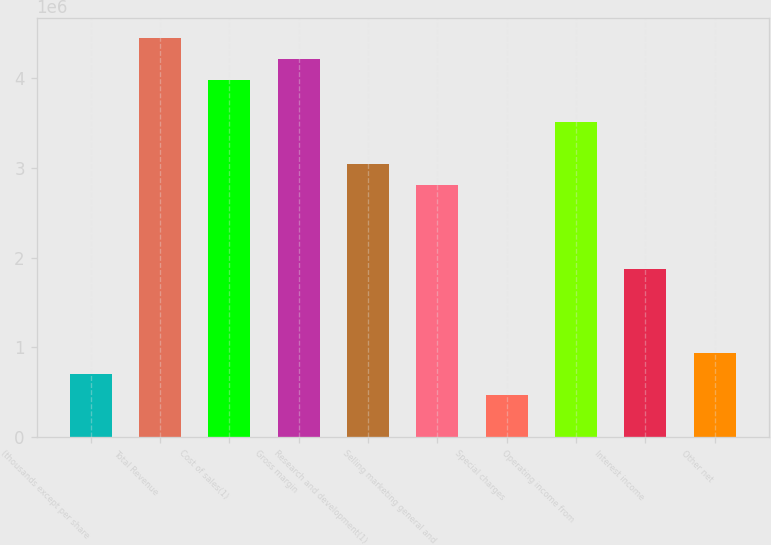<chart> <loc_0><loc_0><loc_500><loc_500><bar_chart><fcel>(thousands except per share<fcel>Total Revenue<fcel>Cost of sales(1)<fcel>Gross margin<fcel>Research and development(1)<fcel>Selling marketing general and<fcel>Special charges<fcel>Operating income from<fcel>Interest income<fcel>Other net<nl><fcel>702876<fcel>4.45155e+06<fcel>3.98296e+06<fcel>4.21725e+06<fcel>3.04579e+06<fcel>2.8115e+06<fcel>468584<fcel>3.51438e+06<fcel>1.87434e+06<fcel>937168<nl></chart> 